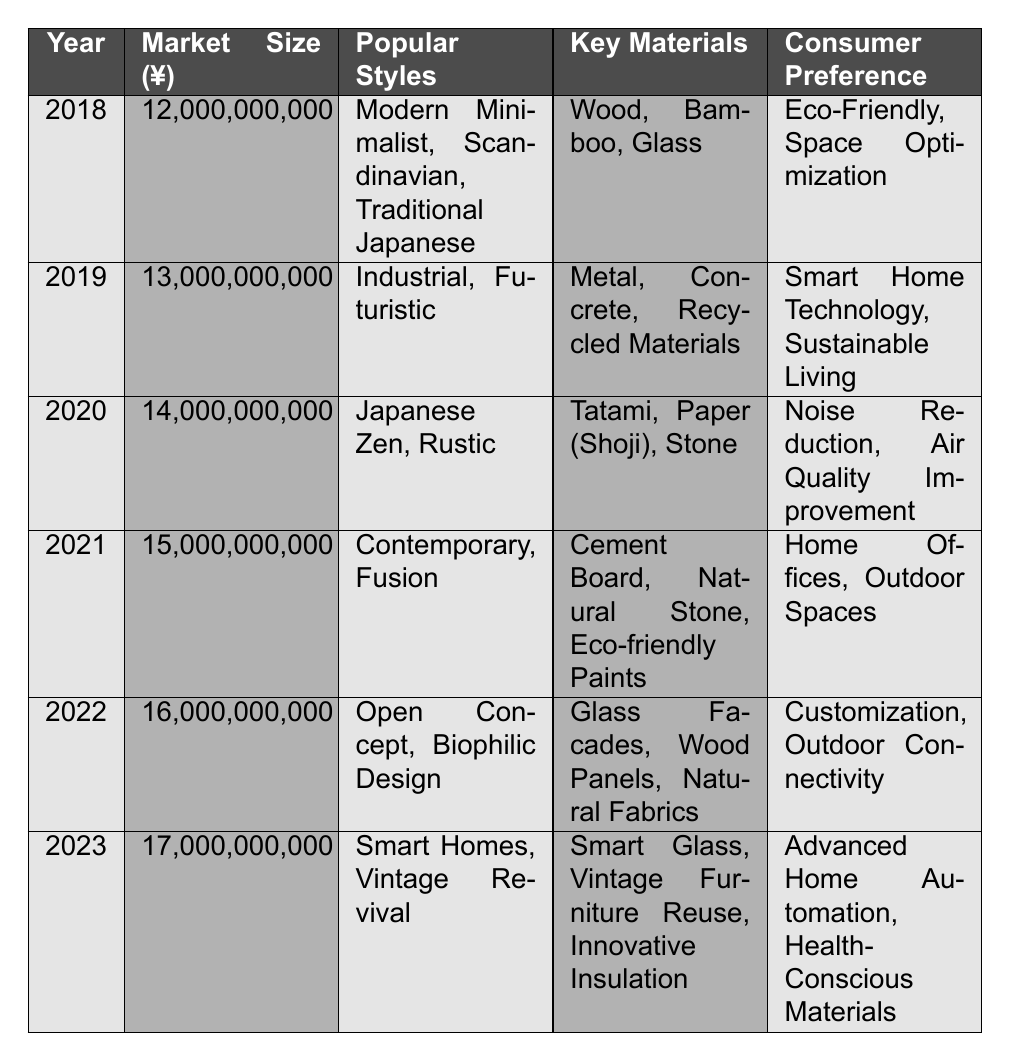What was the market size in 2021? The table indicates that the market size for the year 2021 is listed under the "Market Size (¥)" column, which shows a value of 15,000,000,000.
Answer: 15,000,000,000 Which popular style was noted in 2020? According to the "Popular Styles" column for the year 2020, the noted styles are "Japanese Zen" and "Rustic."
Answer: Japanese Zen, Rustic What are the key materials used in home renovation in 2022? The table specifies that the key materials for 2022 include "Glass Facades," "Wood Panels," and "Natural Fabrics" in the "Key Materials" column.
Answer: Glass Facades, Wood Panels, Natural Fabrics Was "Smart Home Technology" a consumer preference in 2018? The table shows that "Smart Home Technology" is listed as a consumer preference for the year 2019 and not for 2018, so it is false for 2018.
Answer: No How much did the market size increase from 2018 to 2023? The market size for 2018 is 12,000,000,000 and for 2023 is 17,000,000,000. Calculating the difference: 17,000,000,000 - 12,000,000,000 = 5,000,000,000.
Answer: 5,000,000,000 What are the consumer preferences for 2021 and how do they compare to those in 2023? The consumer preferences for 2021 are "Home Offices" and "Outdoor Spaces," while for 2023 they are "Advanced Home Automation" and "Health-Conscious Materials." This indicates a shift from more traditional space needs to a focus on technology and health.
Answer: Shift in preferences Which year had the most popular styles listed, "Open Concept" and "Biophilic Design"? The year that features "Open Concept" and "Biophilic Design" under the "Popular Styles" column is 2022.
Answer: 2022 What was the total market size from 2018 to 2023? To find the total, add the market sizes for each year: (12,000,000,000 + 13,000,000,000 + 14,000,000,000 + 15,000,000,000 + 16,000,000,000 + 17,000,000,000) = 87,000,000,000.
Answer: 87,000,000,000 In which year did "Vintage Revival" become a popular style? The table indicates that "Vintage Revival" was listed as a popular style in the year 2023.
Answer: 2023 How do the notable projects of 2020 differ from those in 2021? Notable projects in 2020 include "Kyoto Tea House Restoration" and "Modern Sukiya Style Home," while in 2021, they are "Rehabilitation of Traditional Townhouses" and "Nishijin Textile House." This shows a trend from restoration to rehabilitation.
Answer: Restoration to rehabilitation trend 